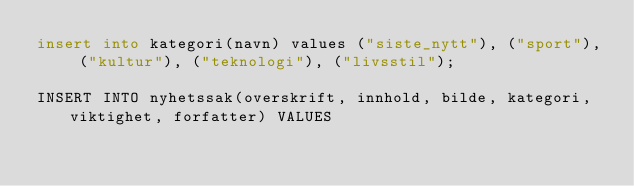<code> <loc_0><loc_0><loc_500><loc_500><_SQL_>insert into kategori(navn) values ("siste_nytt"), ("sport"), ("kultur"), ("teknologi"), ("livsstil");

INSERT INTO nyhetssak(overskrift, innhold, bilde, kategori, viktighet, forfatter) VALUES</code> 